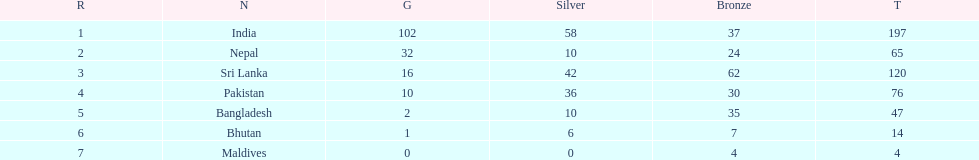How many gold medals did india win? 102. 